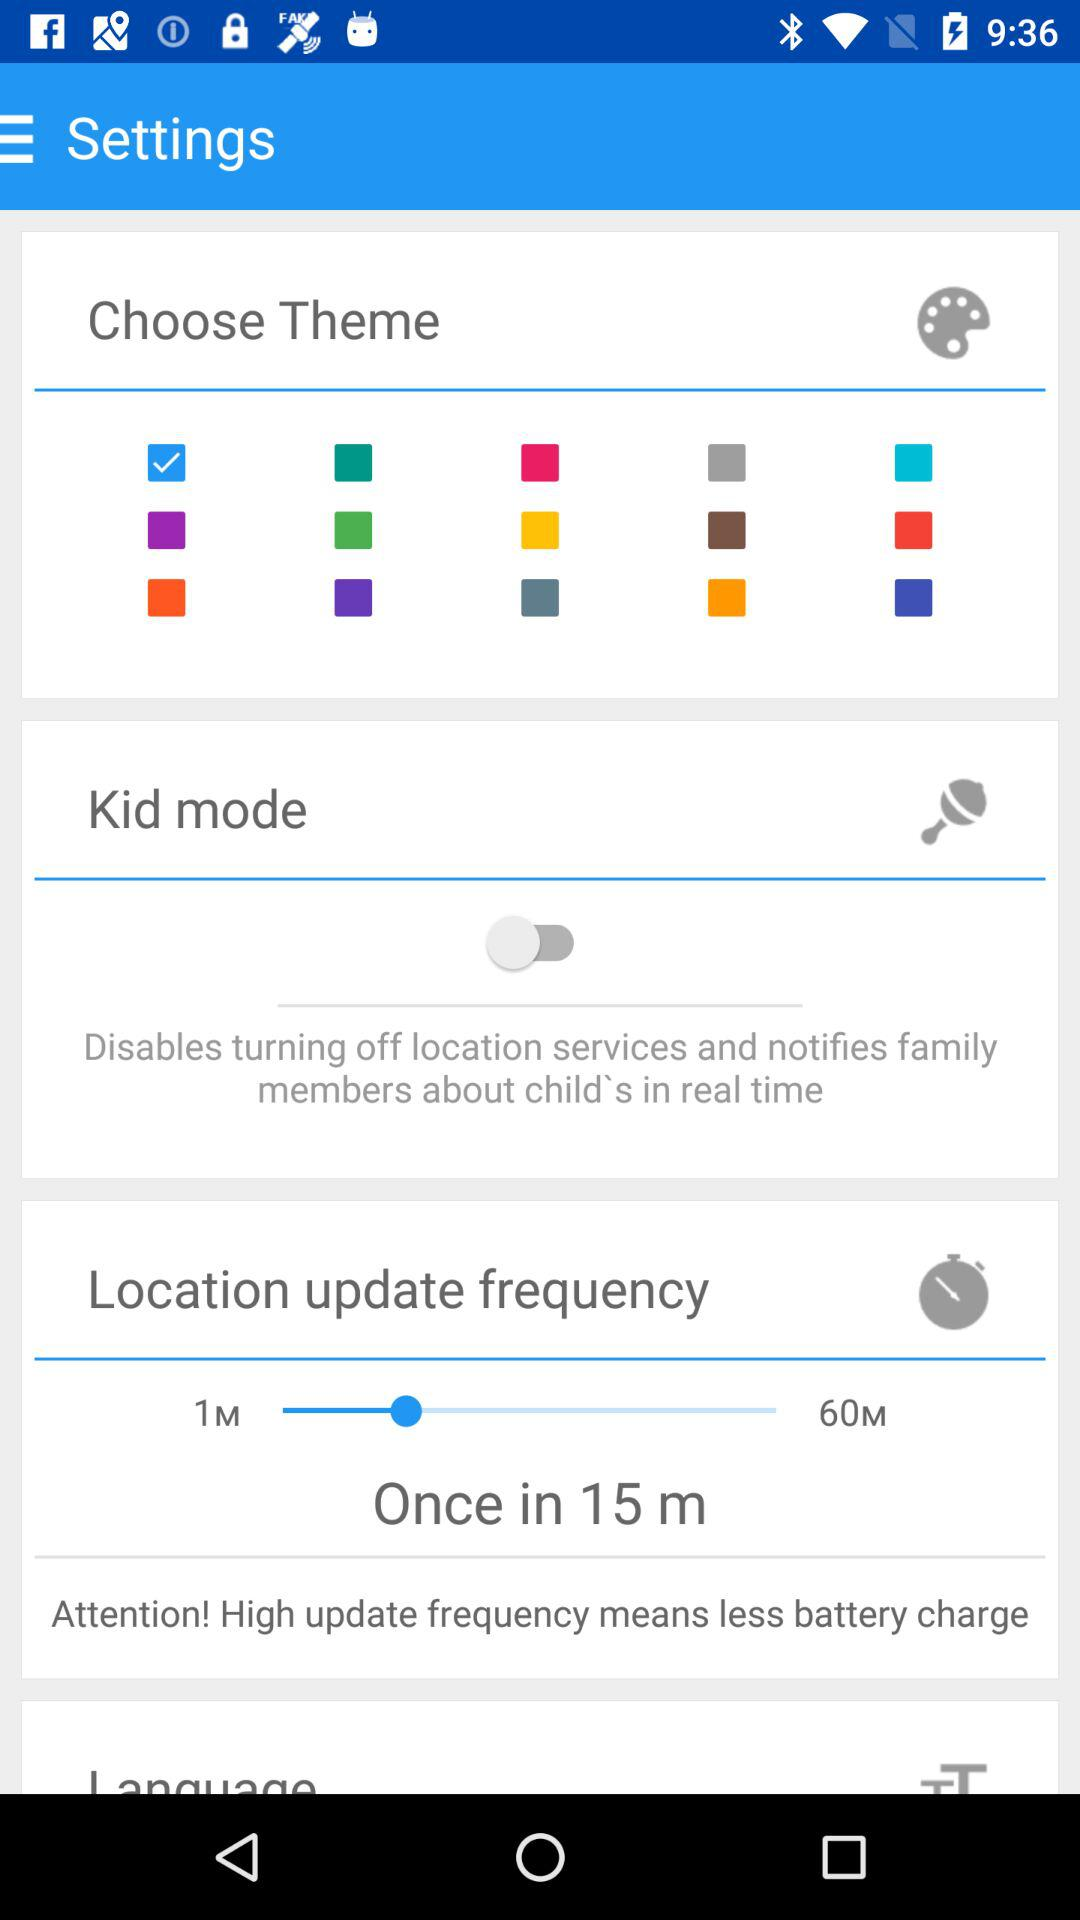What is the status of "Kid mode"? The status of "Kid mode" is "off". 